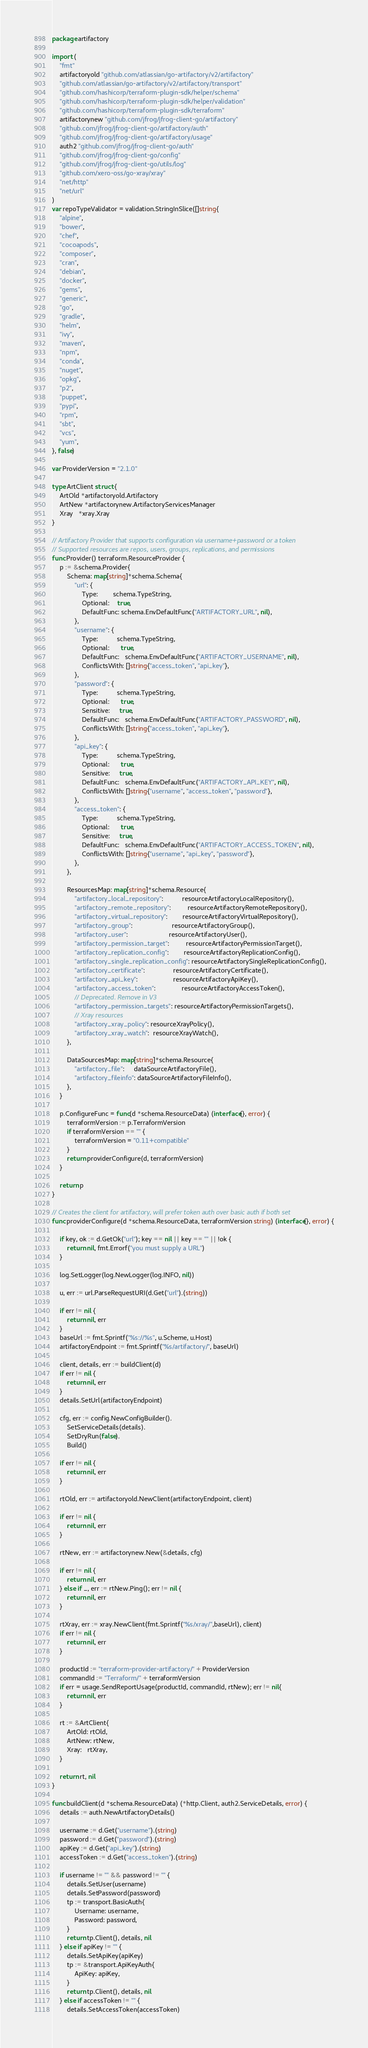<code> <loc_0><loc_0><loc_500><loc_500><_Go_>package artifactory

import (
	"fmt"
	artifactoryold "github.com/atlassian/go-artifactory/v2/artifactory"
	"github.com/atlassian/go-artifactory/v2/artifactory/transport"
	"github.com/hashicorp/terraform-plugin-sdk/helper/schema"
	"github.com/hashicorp/terraform-plugin-sdk/helper/validation"
	"github.com/hashicorp/terraform-plugin-sdk/terraform"
	artifactorynew "github.com/jfrog/jfrog-client-go/artifactory"
	"github.com/jfrog/jfrog-client-go/artifactory/auth"
	"github.com/jfrog/jfrog-client-go/artifactory/usage"
	auth2 "github.com/jfrog/jfrog-client-go/auth"
	"github.com/jfrog/jfrog-client-go/config"
	"github.com/jfrog/jfrog-client-go/utils/log"
	"github.com/xero-oss/go-xray/xray"
	"net/http"
	"net/url"
)
var repoTypeValidator = validation.StringInSlice([]string{
	"alpine",
	"bower",
	"chef",
	"cocoapods",
	"composer",
	"cran",
	"debian",
	"docker",
	"gems",
	"generic",
	"go",
	"gradle",
	"helm",
	"ivy",
	"maven",
	"npm",
	"conda",
	"nuget",
	"opkg",
	"p2",
	"puppet",
	"pypi",
	"rpm",
	"sbt",
	"vcs",
	"yum",
}, false)

var ProviderVersion = "2.1.0"

type ArtClient struct {
	ArtOld *artifactoryold.Artifactory
	ArtNew *artifactorynew.ArtifactoryServicesManager
	Xray   *xray.Xray
}

// Artifactory Provider that supports configuration via username+password or a token
// Supported resources are repos, users, groups, replications, and permissions
func Provider() terraform.ResourceProvider {
	p := &schema.Provider{
		Schema: map[string]*schema.Schema{
			"url": {
				Type:        schema.TypeString,
				Optional:    true,
				DefaultFunc: schema.EnvDefaultFunc("ARTIFACTORY_URL", nil),
			},
			"username": {
				Type:          schema.TypeString,
				Optional:      true,
				DefaultFunc:   schema.EnvDefaultFunc("ARTIFACTORY_USERNAME", nil),
				ConflictsWith: []string{"access_token", "api_key"},
			},
			"password": {
				Type:          schema.TypeString,
				Optional:      true,
				Sensitive:     true,
				DefaultFunc:   schema.EnvDefaultFunc("ARTIFACTORY_PASSWORD", nil),
				ConflictsWith: []string{"access_token", "api_key"},
			},
			"api_key": {
				Type:          schema.TypeString,
				Optional:      true,
				Sensitive:     true,
				DefaultFunc:   schema.EnvDefaultFunc("ARTIFACTORY_API_KEY", nil),
				ConflictsWith: []string{"username", "access_token", "password"},
			},
			"access_token": {
				Type:          schema.TypeString,
				Optional:      true,
				Sensitive:     true,
				DefaultFunc:   schema.EnvDefaultFunc("ARTIFACTORY_ACCESS_TOKEN", nil),
				ConflictsWith: []string{"username", "api_key", "password"},
			},
		},

		ResourcesMap: map[string]*schema.Resource{
			"artifactory_local_repository":          resourceArtifactoryLocalRepository(),
			"artifactory_remote_repository":         resourceArtifactoryRemoteRepository(),
			"artifactory_virtual_repository":        resourceArtifactoryVirtualRepository(),
			"artifactory_group":                     resourceArtifactoryGroup(),
			"artifactory_user":                      resourceArtifactoryUser(),
			"artifactory_permission_target":         resourceArtifactoryPermissionTarget(),
			"artifactory_replication_config":        resourceArtifactoryReplicationConfig(),
			"artifactory_single_replication_config": resourceArtifactorySingleReplicationConfig(),
			"artifactory_certificate":               resourceArtifactoryCertificate(),
			"artifactory_api_key":                   resourceArtifactoryApiKey(),
			"artifactory_access_token":              resourceArtifactoryAccessToken(),
			// Deprecated. Remove in V3
			"artifactory_permission_targets": resourceArtifactoryPermissionTargets(),
			// Xray resources
			"artifactory_xray_policy": resourceXrayPolicy(),
			"artifactory_xray_watch":  resourceXrayWatch(),
		},

		DataSourcesMap: map[string]*schema.Resource{
			"artifactory_file":     dataSourceArtifactoryFile(),
			"artifactory_fileinfo": dataSourceArtifactoryFileInfo(),
		},
	}

	p.ConfigureFunc = func(d *schema.ResourceData) (interface{}, error) {
		terraformVersion := p.TerraformVersion
		if terraformVersion == "" {
			terraformVersion = "0.11+compatible"
		}
		return providerConfigure(d, terraformVersion)
	}

	return p
}

// Creates the client for artifactory, will prefer token auth over basic auth if both set
func providerConfigure(d *schema.ResourceData, terraformVersion string) (interface{}, error) {

	if key, ok := d.GetOk("url"); key == nil || key == "" || !ok {
		return nil, fmt.Errorf("you must supply a URL")
	}

	log.SetLogger(log.NewLogger(log.INFO, nil))

	u, err := url.ParseRequestURI(d.Get("url").(string))

	if err != nil {
		return nil, err
	}
	baseUrl := fmt.Sprintf("%s://%s", u.Scheme, u.Host)
	artifactoryEndpoint := fmt.Sprintf("%s/artifactory/", baseUrl)

	client, details, err := buildClient(d)
	if err != nil {
		return nil, err
	}
	details.SetUrl(artifactoryEndpoint)

	cfg, err := config.NewConfigBuilder().
		SetServiceDetails(details).
		SetDryRun(false).
		Build()

	if err != nil {
		return nil, err
	}

	rtOld, err := artifactoryold.NewClient(artifactoryEndpoint, client)

	if err != nil {
		return nil, err
	}

	rtNew, err := artifactorynew.New(&details, cfg)

	if err != nil {
		return nil, err
	} else if _, err := rtNew.Ping(); err != nil {
		return nil, err
	}

	rtXray, err := xray.NewClient(fmt.Sprintf("%s/xray/",baseUrl), client)
	if err != nil {
		return nil, err
	}

	productId := "terraform-provider-artifactory/" + ProviderVersion
	commandId := "Terraform/" + terraformVersion
	if err = usage.SendReportUsage(productId, commandId, rtNew); err != nil{
		return nil, err
	}

	rt := &ArtClient{
		ArtOld: rtOld,
		ArtNew: rtNew,
		Xray:   rtXray,
	}

	return rt, nil
}

func buildClient(d *schema.ResourceData) (*http.Client, auth2.ServiceDetails, error) {
	details := auth.NewArtifactoryDetails()

	username := d.Get("username").(string)
	password := d.Get("password").(string)
	apiKey := d.Get("api_key").(string)
	accessToken := d.Get("access_token").(string)

	if username != "" && password != "" {
		details.SetUser(username)
		details.SetPassword(password)
		tp := transport.BasicAuth{
			Username: username,
			Password: password,
		}
		return tp.Client(), details, nil
	} else if apiKey != "" {
		details.SetApiKey(apiKey)
		tp := &transport.ApiKeyAuth{
			ApiKey: apiKey,
		}
		return tp.Client(), details, nil
	} else if accessToken != "" {
		details.SetAccessToken(accessToken)</code> 